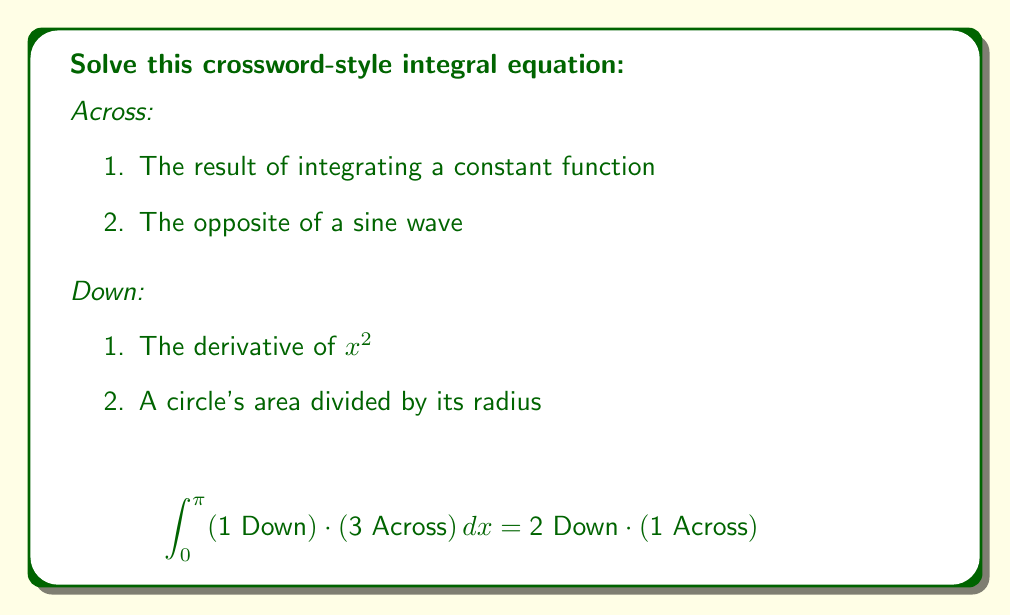Help me with this question. Let's solve this step-by-step:

1. First, we need to identify the clues:
   - 1 Across: The result of integrating a constant function is $x$
   - 3 Across: The opposite of a sine wave is cosine, or $\cos x$
   - 1 Down: The derivative of $x^2$ is $2x$
   - 2 Down: A circle's area ($\pi r^2$) divided by its radius ($r$) is $\pi r$

2. Now, let's substitute these into our equation:

   $$\int_{0}^{\pi} (2x) \cdot (\cos x) \, dx = \pi r \cdot x$$

3. To solve the left side, we can use integration by parts:
   Let $u = 2x$ and $dv = \cos x \, dx$
   Then $du = 2 \, dx$ and $v = \sin x$

   $$\int (2x)(\cos x) \, dx = 2x \sin x - \int 2 \sin x \, dx$$
   $$= 2x \sin x + 2 \cos x + C$$

4. Now, let's evaluate from 0 to $\pi$:

   $$[2x \sin x + 2 \cos x]_0^\pi = (2\pi \sin \pi + 2 \cos \pi) - (0 + 2)$$
   $$= 0 - 2 - 2 = -4$$

5. So our equation becomes:

   $$-4 = \pi r \cdot x$$

6. Since $x$ is a variable (representing the result of integrating a constant), we can set it to 1 for simplicity. Then:

   $$-4 = \pi r$$
   $$r = -\frac{4}{\pi}$$

Therefore, the radius $r$ that satisfies this equation is $-\frac{4}{\pi}$.
Answer: $-\frac{4}{\pi}$ 